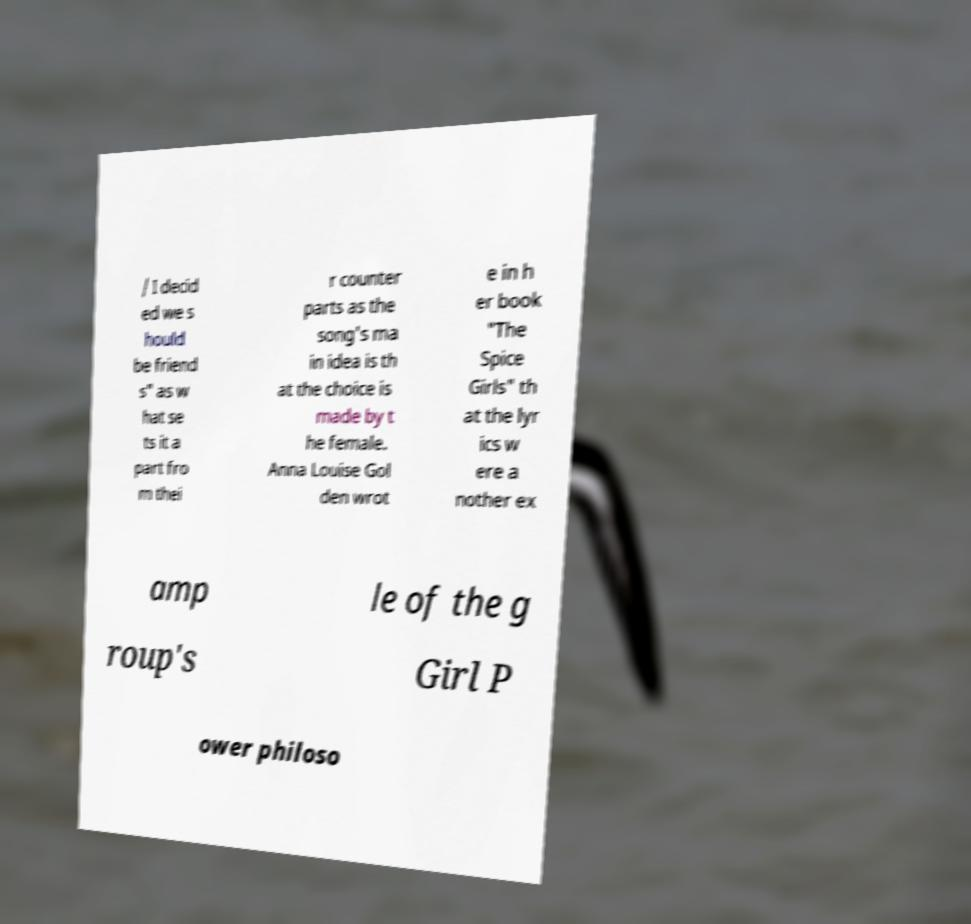Please identify and transcribe the text found in this image. / I decid ed we s hould be friend s" as w hat se ts it a part fro m thei r counter parts as the song's ma in idea is th at the choice is made by t he female. Anna Louise Gol den wrot e in h er book "The Spice Girls" th at the lyr ics w ere a nother ex amp le of the g roup's Girl P ower philoso 